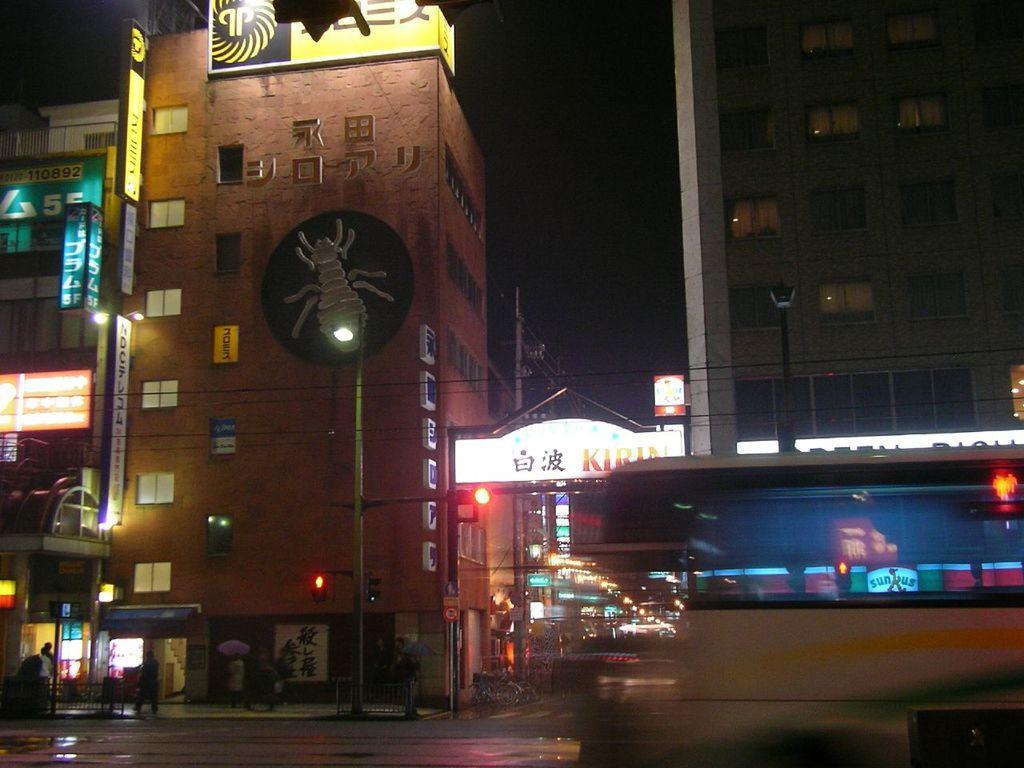How would you summarize this image in a sentence or two? In this image in the middle, there are many buildings, street lights, posters, text, lightnings, some people and road. On the right there is a vehicle. 